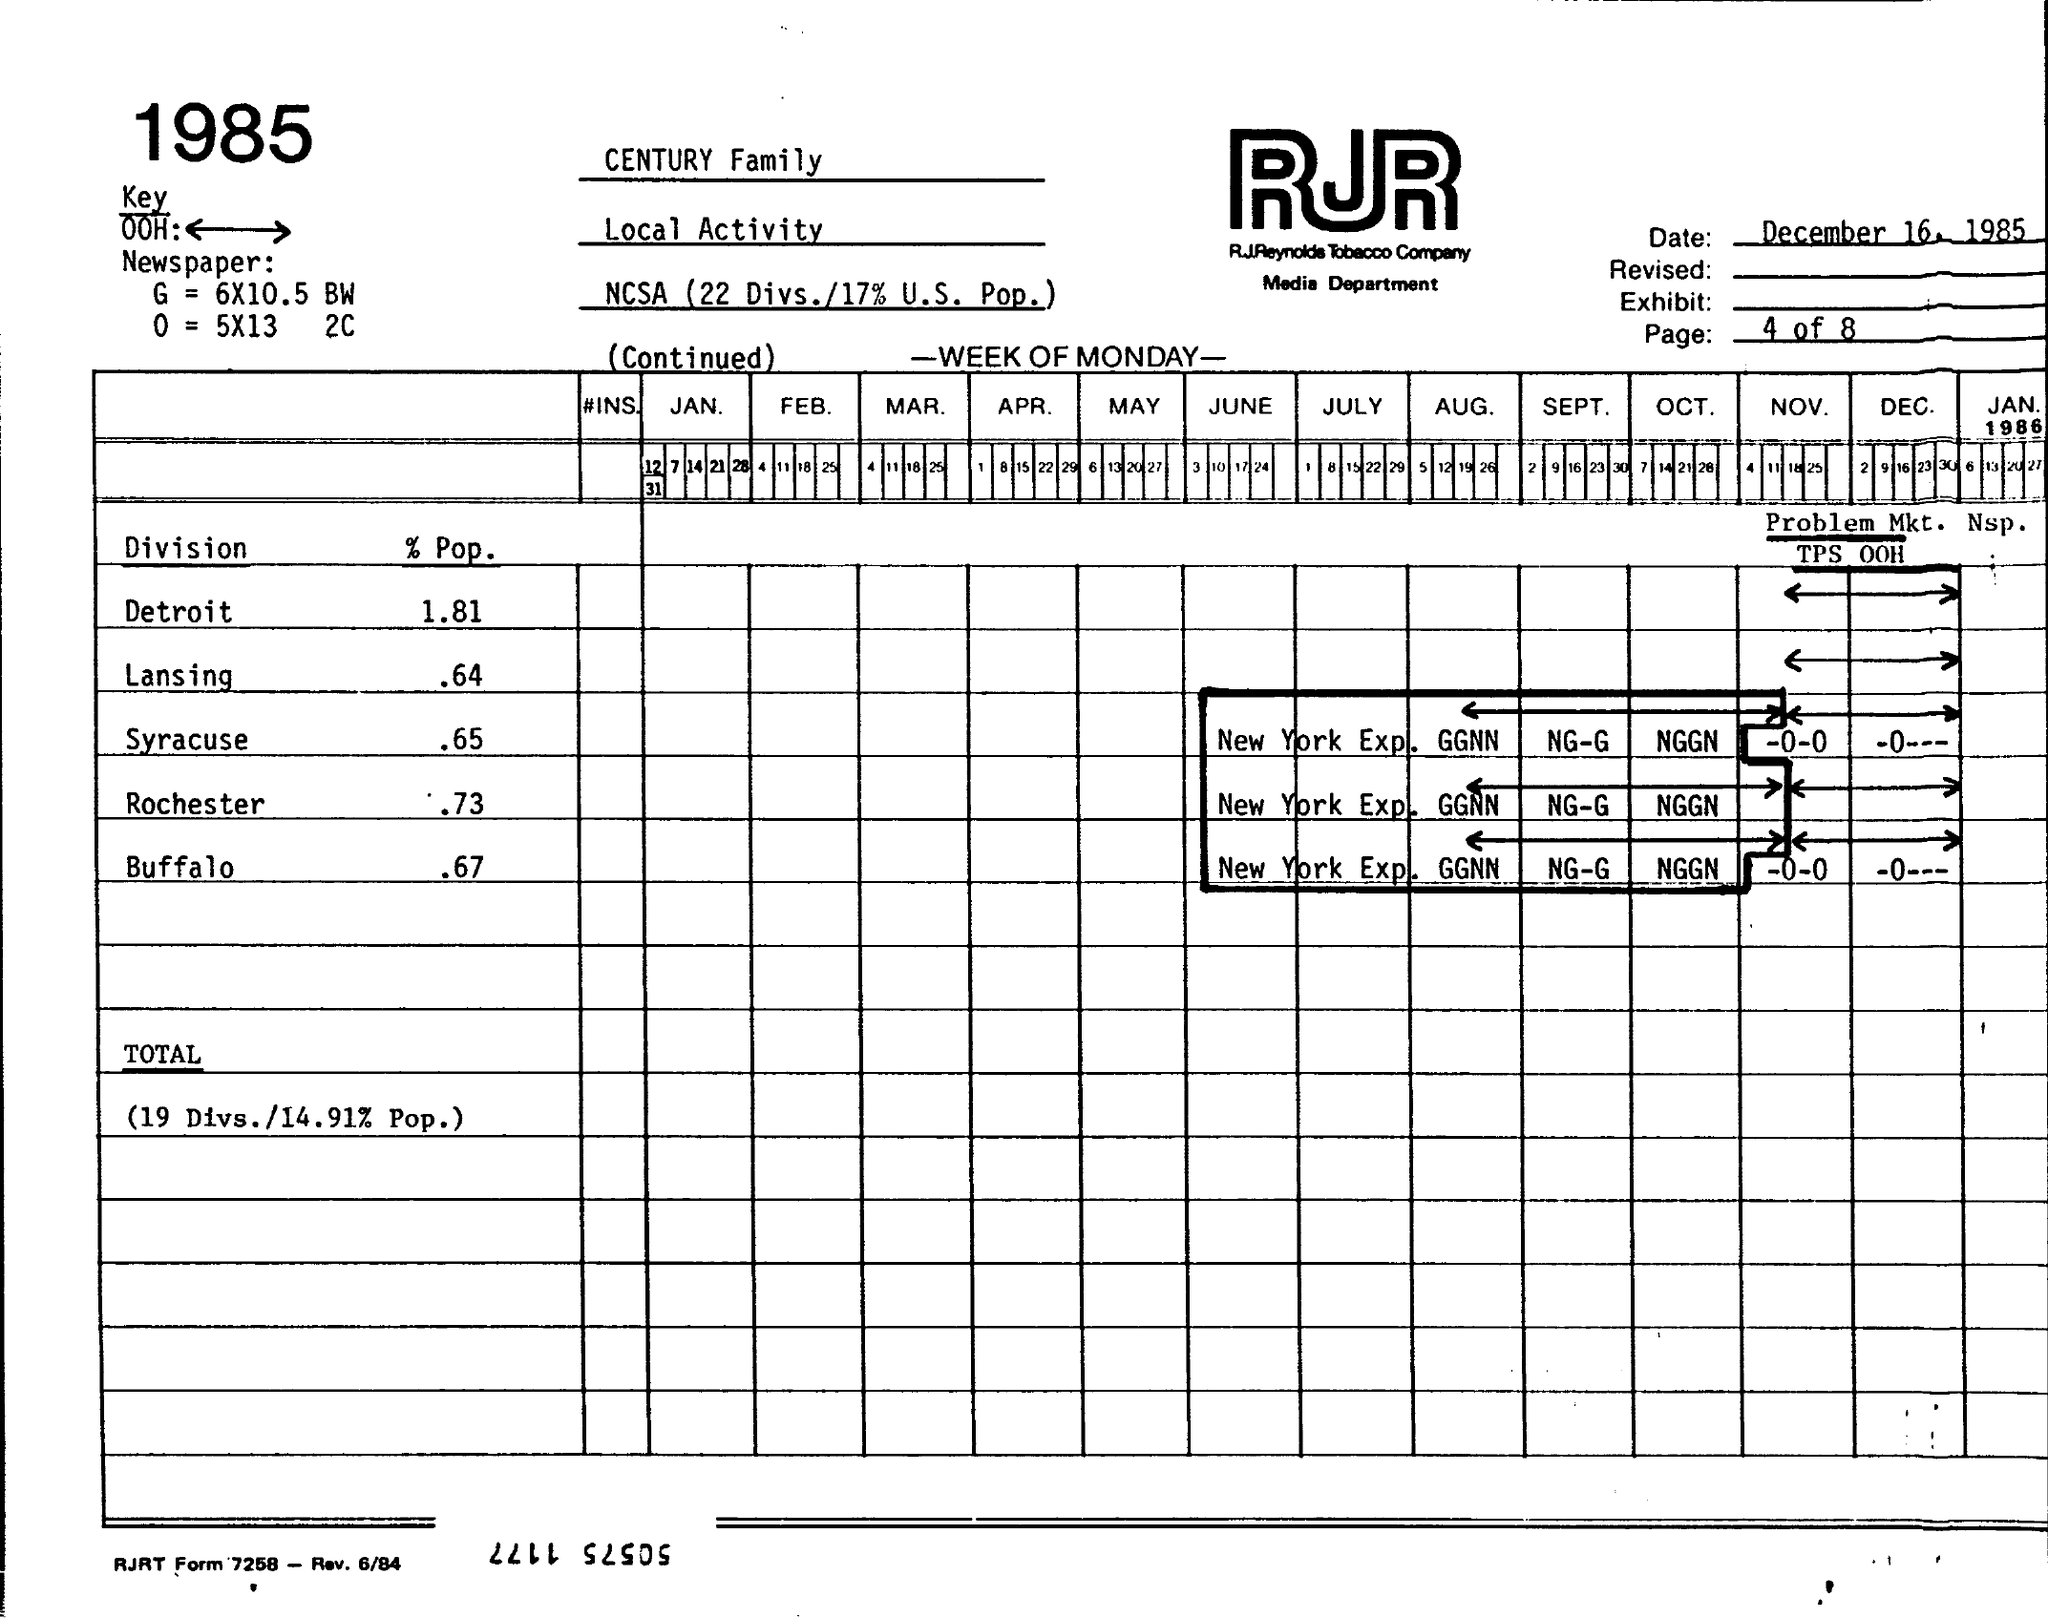Can you tell me more about the context of this image? The image appears to be a scan of a historical document, specifically a media planning form from RJR Reynolds Tobacco Company, dated December 16, 1985. It includes information such as local activity, key markets, and population percentages for different divisions like Detroit, Lansing, and others, likely for advertising or market analysis purposes. 